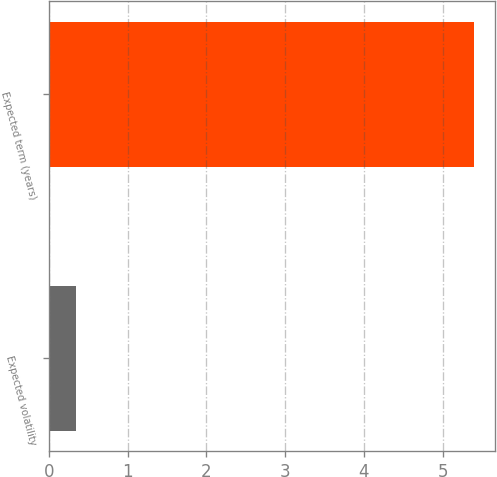<chart> <loc_0><loc_0><loc_500><loc_500><bar_chart><fcel>Expected volatility<fcel>Expected term (years)<nl><fcel>0.35<fcel>5.4<nl></chart> 